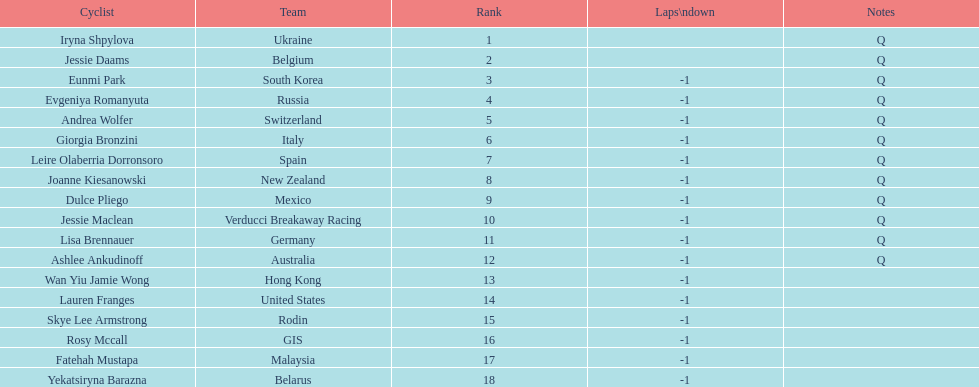Can you parse all the data within this table? {'header': ['Cyclist', 'Team', 'Rank', 'Laps\\ndown', 'Notes'], 'rows': [['Iryna Shpylova', 'Ukraine', '1', '', 'Q'], ['Jessie Daams', 'Belgium', '2', '', 'Q'], ['Eunmi Park', 'South Korea', '3', '-1', 'Q'], ['Evgeniya Romanyuta', 'Russia', '4', '-1', 'Q'], ['Andrea Wolfer', 'Switzerland', '5', '-1', 'Q'], ['Giorgia Bronzini', 'Italy', '6', '-1', 'Q'], ['Leire Olaberria Dorronsoro', 'Spain', '7', '-1', 'Q'], ['Joanne Kiesanowski', 'New Zealand', '8', '-1', 'Q'], ['Dulce Pliego', 'Mexico', '9', '-1', 'Q'], ['Jessie Maclean', 'Verducci Breakaway Racing', '10', '-1', 'Q'], ['Lisa Brennauer', 'Germany', '11', '-1', 'Q'], ['Ashlee Ankudinoff', 'Australia', '12', '-1', 'Q'], ['Wan Yiu Jamie Wong', 'Hong Kong', '13', '-1', ''], ['Lauren Franges', 'United States', '14', '-1', ''], ['Skye Lee Armstrong', 'Rodin', '15', '-1', ''], ['Rosy Mccall', 'GIS', '16', '-1', ''], ['Fatehah Mustapa', 'Malaysia', '17', '-1', ''], ['Yekatsiryna Barazna', 'Belarus', '18', '-1', '']]} How many cyclist are not listed with a country team? 3. 